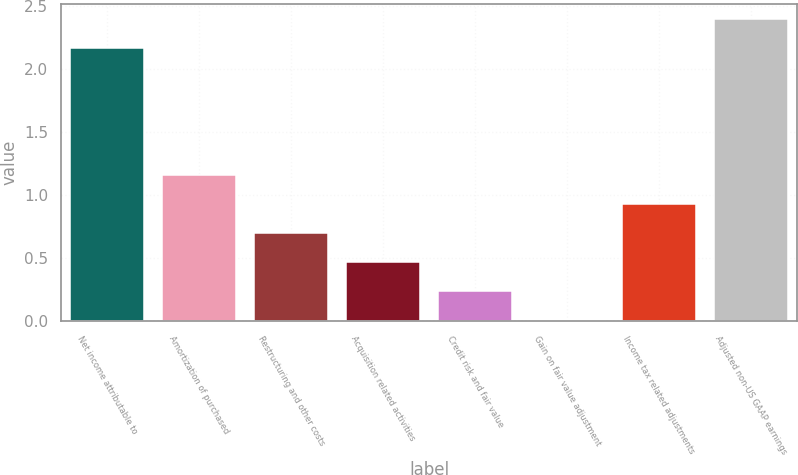Convert chart to OTSL. <chart><loc_0><loc_0><loc_500><loc_500><bar_chart><fcel>Net income attributable to<fcel>Amortization of purchased<fcel>Restructuring and other costs<fcel>Acquisition related activities<fcel>Credit risk and fair value<fcel>Gain on fair value adjustment<fcel>Income tax related adjustments<fcel>Adjusted non-US GAAP earnings<nl><fcel>2.16<fcel>1.16<fcel>0.7<fcel>0.47<fcel>0.24<fcel>0.01<fcel>0.93<fcel>2.39<nl></chart> 